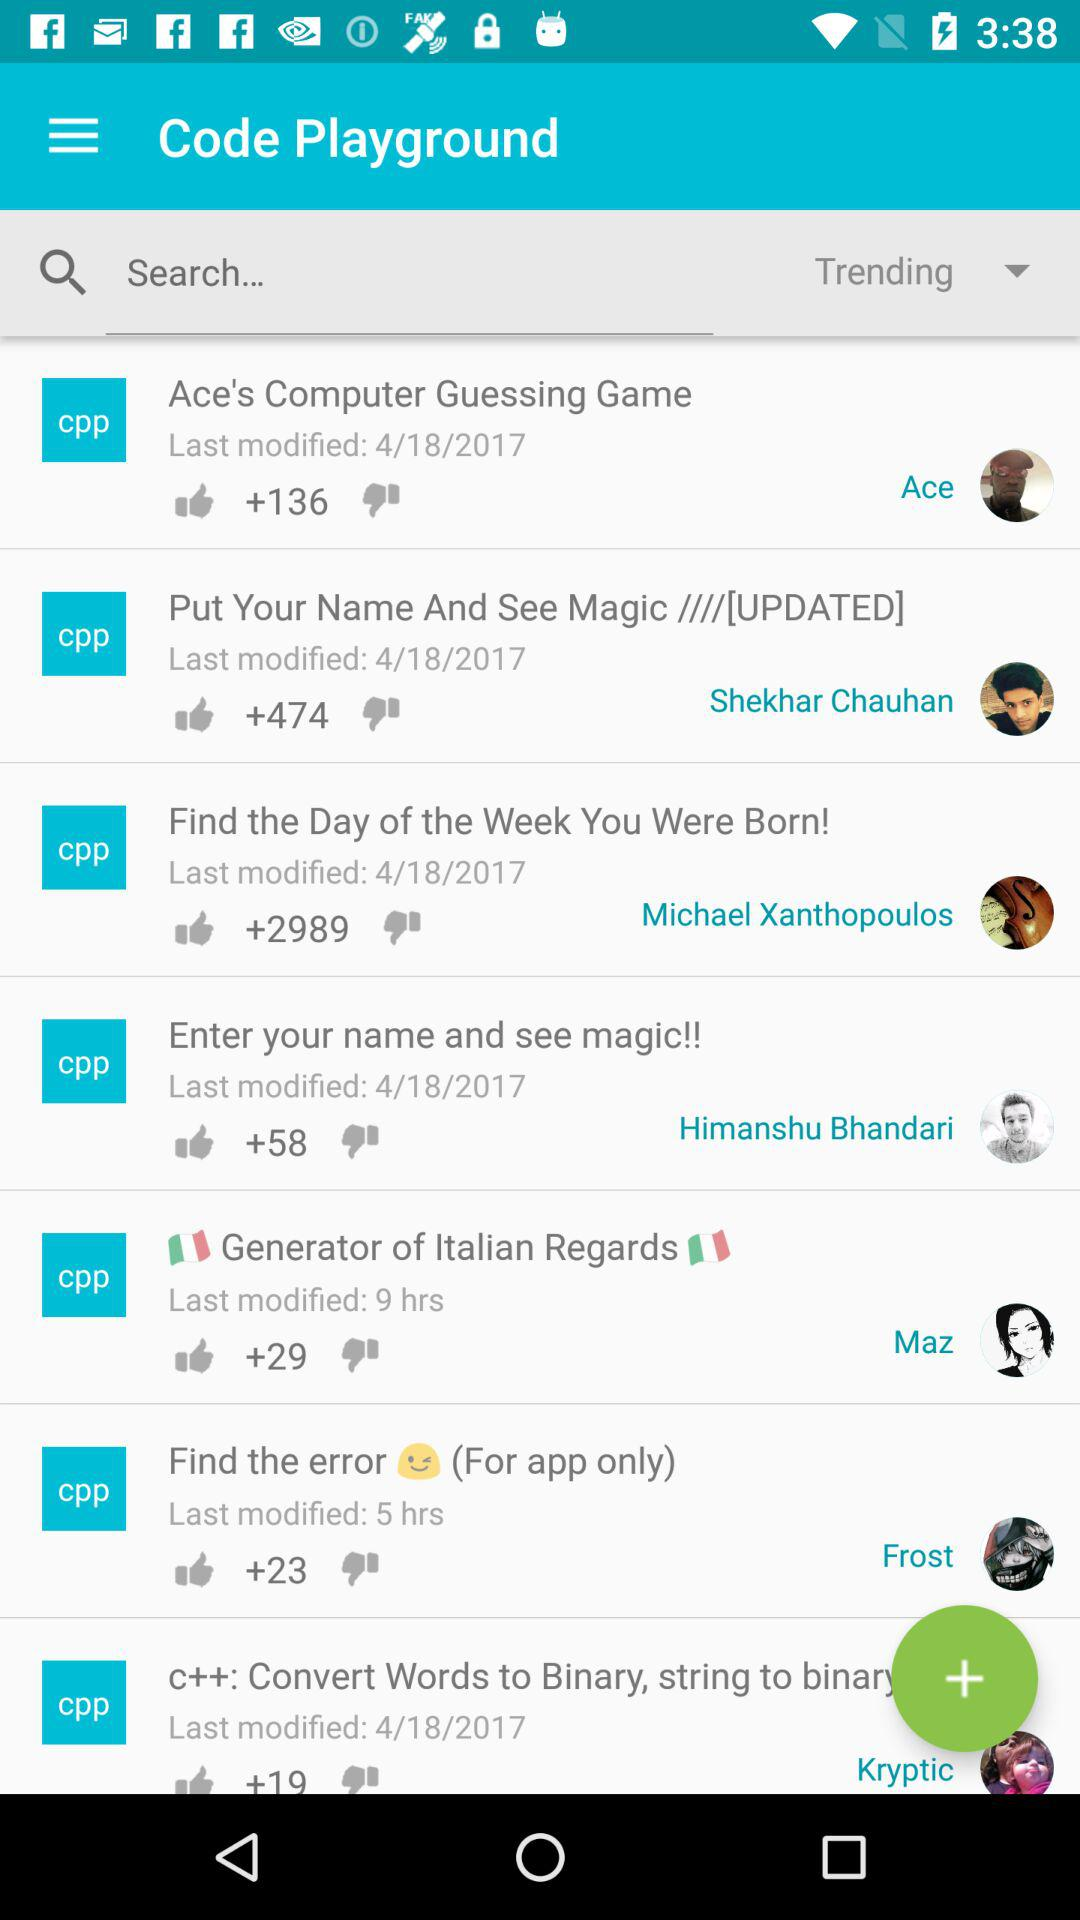Which coding project was modified most recently according to the timestamps? The coding project titled 'Generator of Italian Regards', modified 9 hours ago, appears to be the most recently updated according to the timestamps provided in the image. 